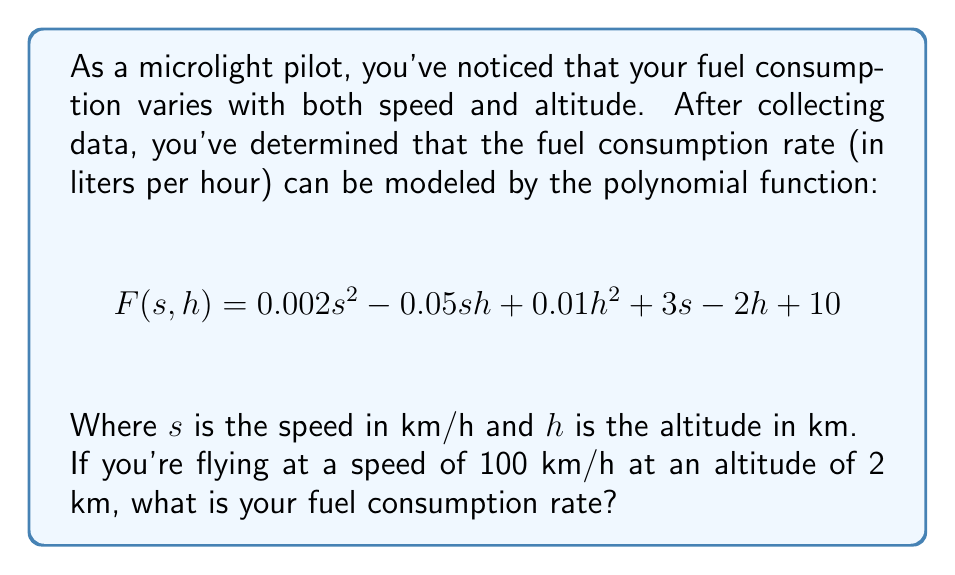Solve this math problem. To solve this problem, we need to substitute the given values into the polynomial function:

$s = 100$ km/h (speed)
$h = 2$ km (altitude)

Let's substitute these values into the function:

$$\begin{align}
F(100, 2) &= 0.002(100)^2 - 0.05(100)(2) + 0.01(2)^2 + 3(100) - 2(2) + 10 \\[10pt]
&= 0.002(10000) - 0.05(200) + 0.01(4) + 300 - 4 + 10 \\[10pt]
&= 20 - 10 + 0.04 + 300 - 4 + 10 \\[10pt]
&= 316.04
\end{align}$$

Let's break down each term:

1. $0.002(100)^2 = 20$
2. $-0.05(100)(2) = -10$
3. $0.01(2)^2 = 0.04$
4. $3(100) = 300$
5. $-2(2) = -4$
6. The constant term is 10

Adding all these terms gives us the final result.
Answer: The fuel consumption rate at a speed of 100 km/h and an altitude of 2 km is 316.04 liters per hour. 